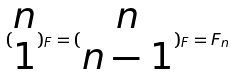Convert formula to latex. <formula><loc_0><loc_0><loc_500><loc_500>( \begin{matrix} n \\ 1 \end{matrix} ) _ { F } = ( \begin{matrix} n \\ n - 1 \end{matrix} ) _ { F } = F _ { n }</formula> 